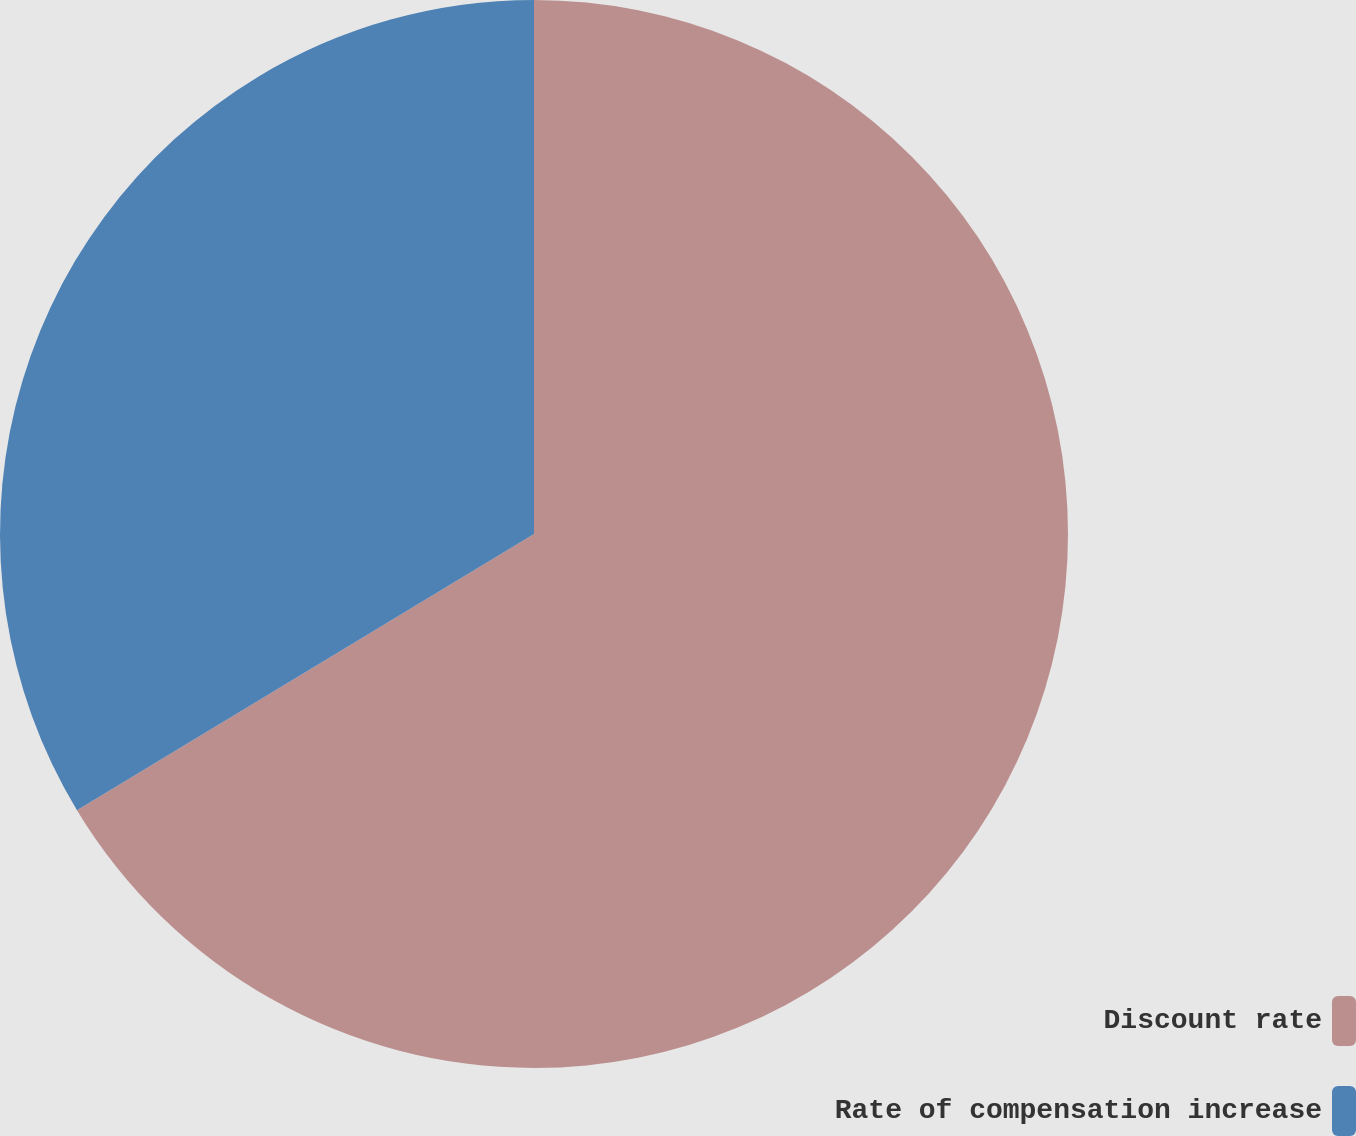Convert chart to OTSL. <chart><loc_0><loc_0><loc_500><loc_500><pie_chart><fcel>Discount rate<fcel>Rate of compensation increase<nl><fcel>66.35%<fcel>33.65%<nl></chart> 